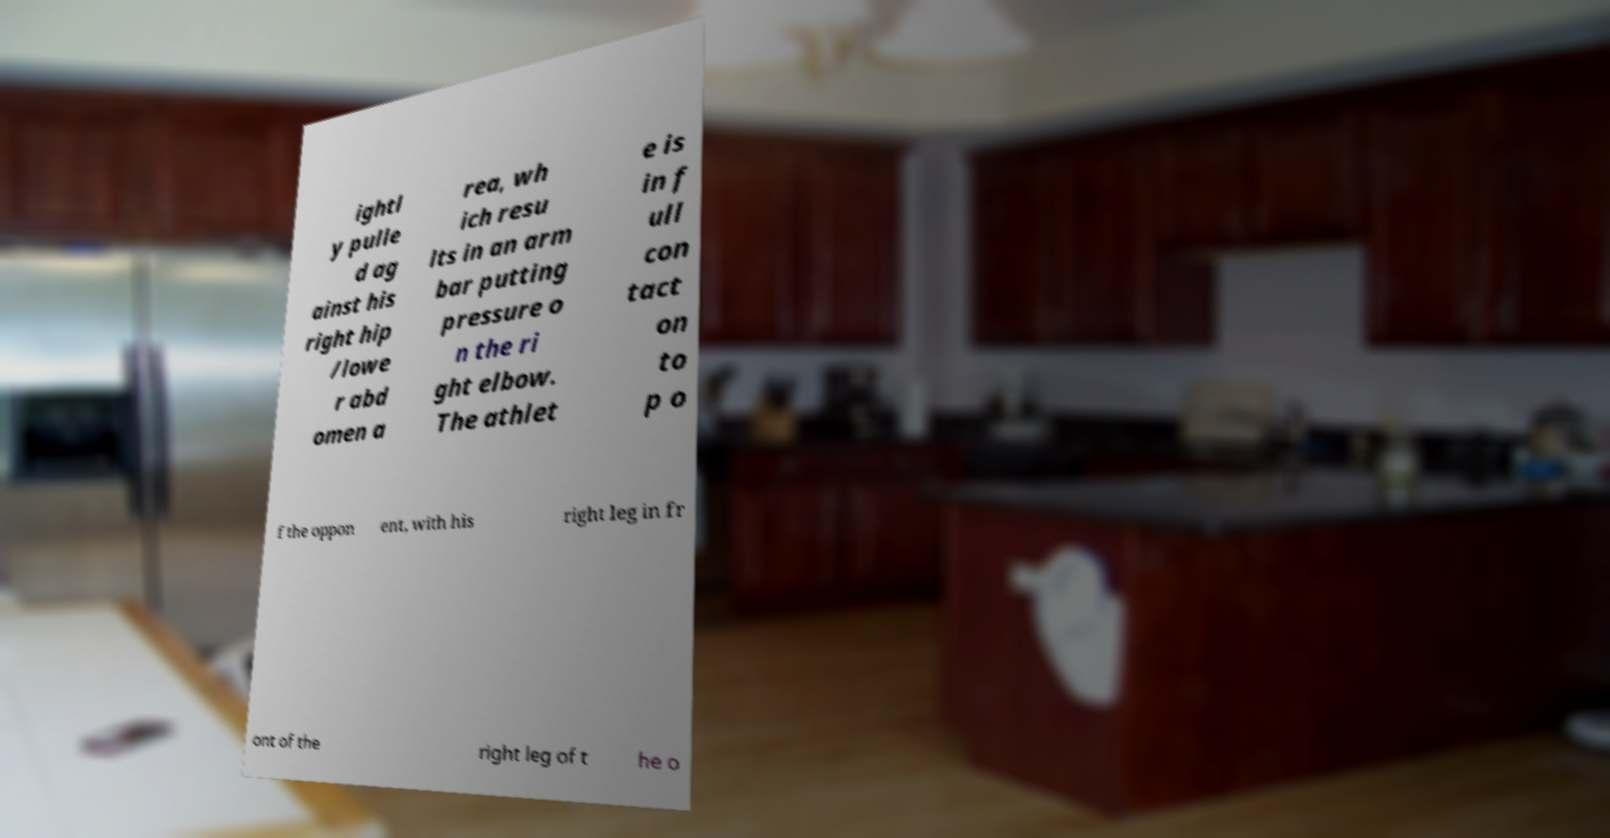Can you read and provide the text displayed in the image?This photo seems to have some interesting text. Can you extract and type it out for me? ightl y pulle d ag ainst his right hip /lowe r abd omen a rea, wh ich resu lts in an arm bar putting pressure o n the ri ght elbow. The athlet e is in f ull con tact on to p o f the oppon ent, with his right leg in fr ont of the right leg of t he o 